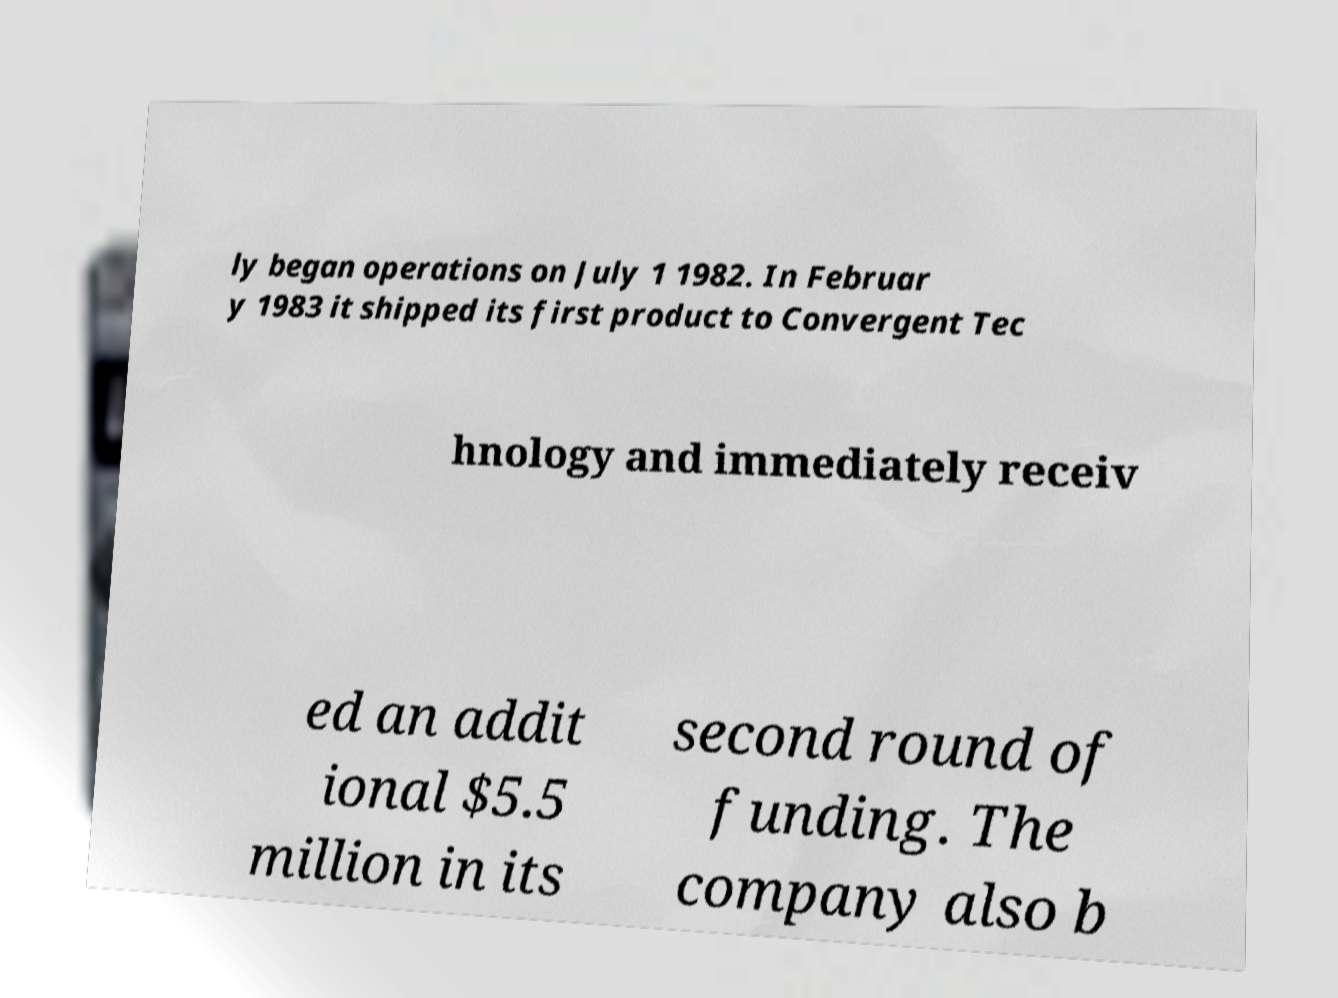Can you read and provide the text displayed in the image?This photo seems to have some interesting text. Can you extract and type it out for me? ly began operations on July 1 1982. In Februar y 1983 it shipped its first product to Convergent Tec hnology and immediately receiv ed an addit ional $5.5 million in its second round of funding. The company also b 